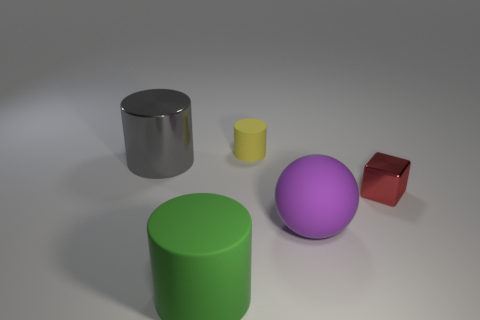Subtract all blue cylinders. Subtract all purple balls. How many cylinders are left? 3 Add 1 large objects. How many objects exist? 6 Subtract all balls. How many objects are left? 4 Subtract 0 yellow balls. How many objects are left? 5 Subtract all blue cylinders. Subtract all cylinders. How many objects are left? 2 Add 3 small rubber cylinders. How many small rubber cylinders are left? 4 Add 1 large yellow metal cubes. How many large yellow metal cubes exist? 1 